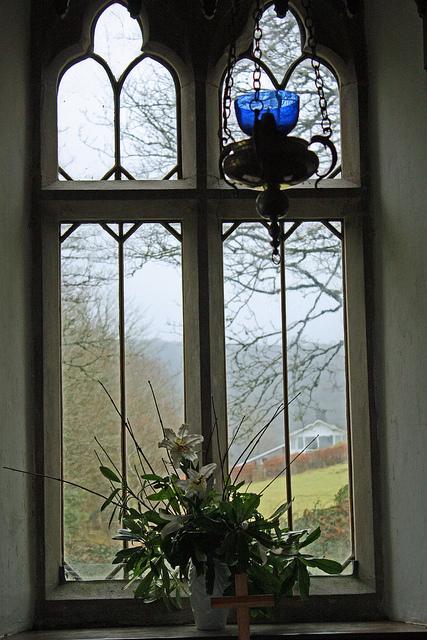What is depicted in the windows?
Write a very short answer. Plant. Is the sky cloudy?
Be succinct. Yes. What color are the flowers?
Concise answer only. White. What time of the day is it?
Be succinct. Daytime. 